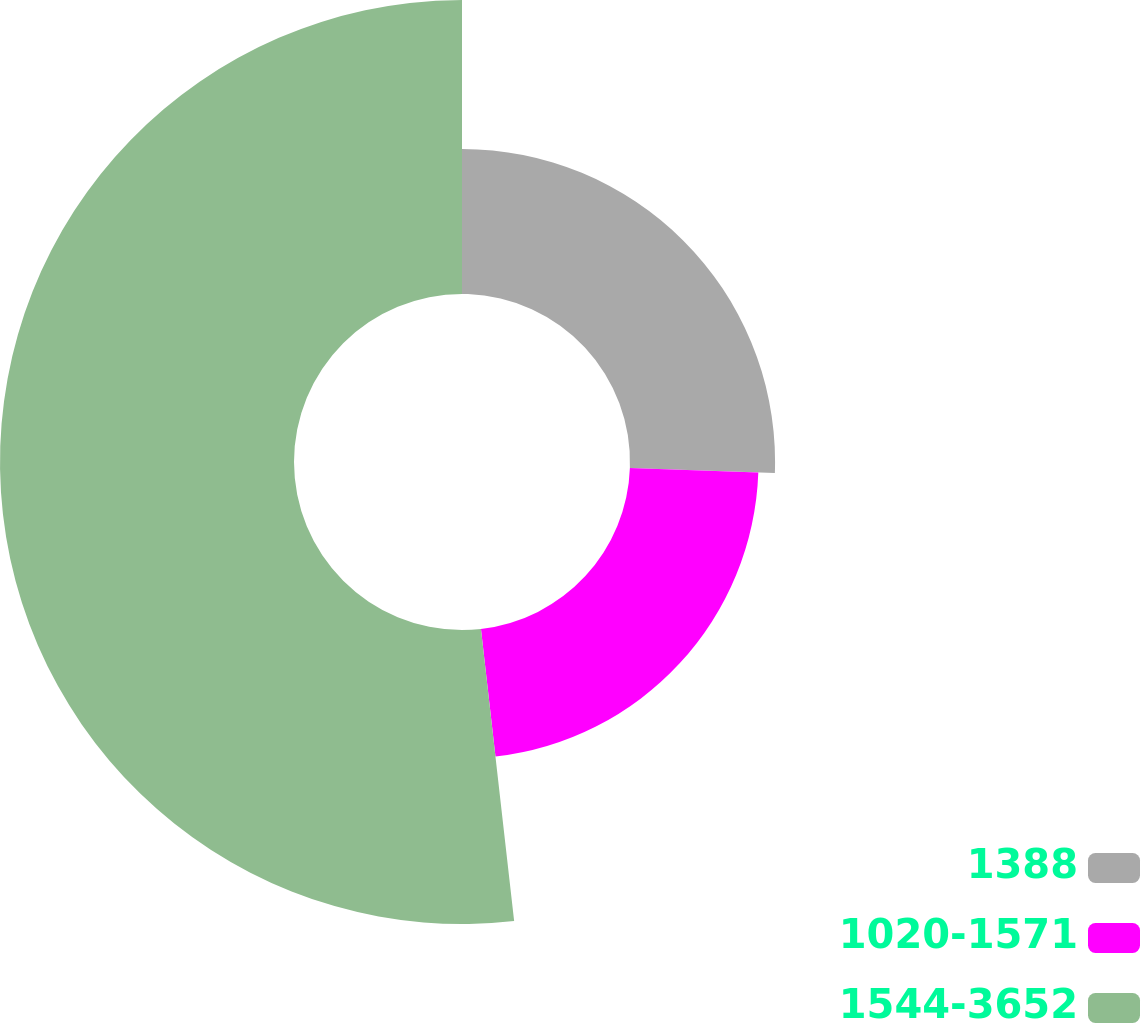Convert chart. <chart><loc_0><loc_0><loc_500><loc_500><pie_chart><fcel>1388<fcel>1020-1571<fcel>1544-3652<nl><fcel>25.56%<fcel>22.64%<fcel>51.8%<nl></chart> 